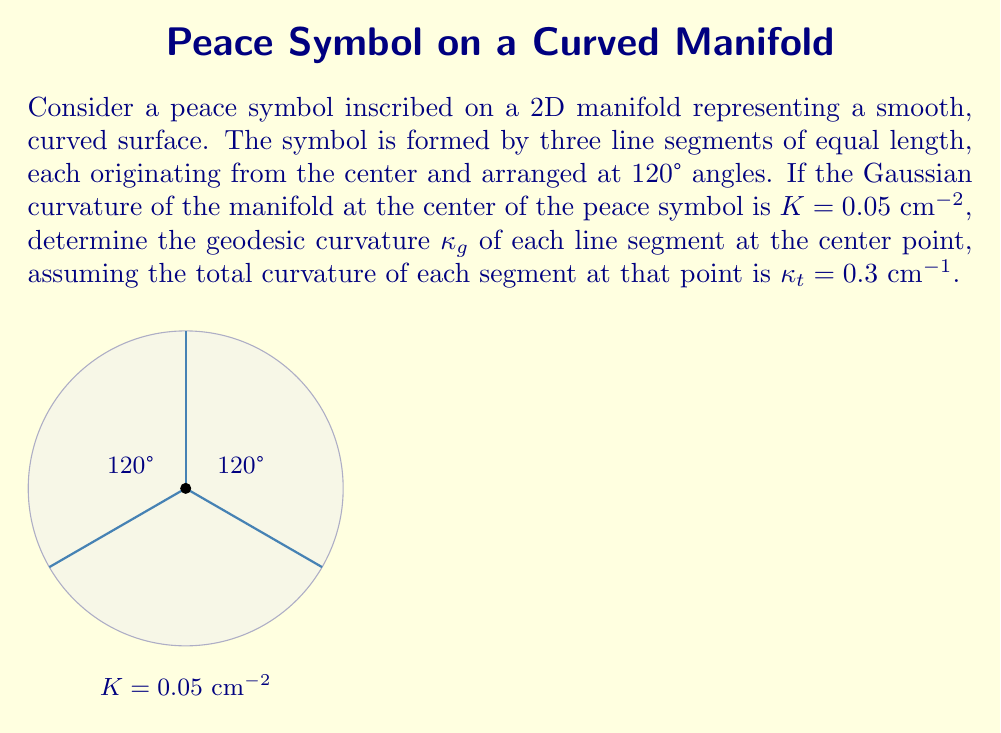Show me your answer to this math problem. To solve this problem, we need to use the relationship between Gaussian curvature, geodesic curvature, and normal curvature on a 2D manifold. Let's approach this step-by-step:

1) On a 2D manifold, the total curvature $\kappa_t$ of a curve at a point is related to its geodesic curvature $\kappa_g$ and normal curvature $\kappa_n$ by:

   $$\kappa_t^2 = \kappa_g^2 + \kappa_n^2$$

2) The normal curvature $\kappa_n$ at a point is related to the Gaussian curvature $K$ by:

   $$\kappa_n = \sqrt{K}$$

3) We are given that $K = 0.05$ cm⁻², so:

   $$\kappa_n = \sqrt{0.05} \approx 0.2236$ cm⁻¹$$

4) We are also given that $\kappa_t = 0.3$ cm⁻¹. Now we can use the relationship from step 1:

   $$0.3^2 = \kappa_g^2 + 0.2236^2$$

5) Solving for $\kappa_g$:

   $$\kappa_g^2 = 0.3^2 - 0.2236^2 = 0.09 - 0.05 = 0.04$$

   $$\kappa_g = \sqrt{0.04} = 0.2$ cm⁻¹$$

Therefore, the geodesic curvature of each line segment at the center point is 0.2 cm⁻¹.
Answer: $\kappa_g = 0.2$ cm⁻¹ 